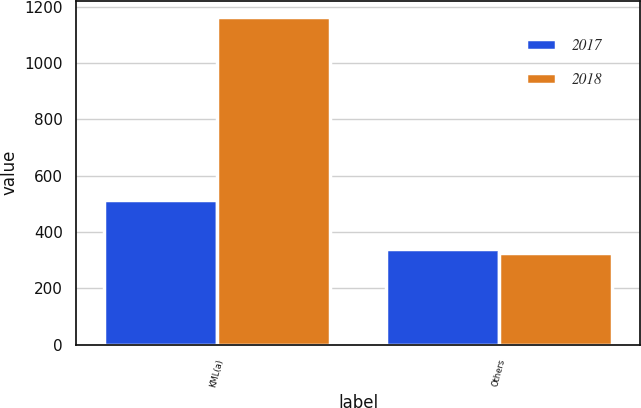<chart> <loc_0><loc_0><loc_500><loc_500><stacked_bar_chart><ecel><fcel>KML(a)<fcel>Others<nl><fcel>2017<fcel>514<fcel>339<nl><fcel>2018<fcel>1163<fcel>325<nl></chart> 